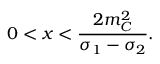Convert formula to latex. <formula><loc_0><loc_0><loc_500><loc_500>0 < x < \frac { 2 m _ { C } ^ { 2 } } { \sigma _ { 1 } - \sigma _ { 2 } } .</formula> 